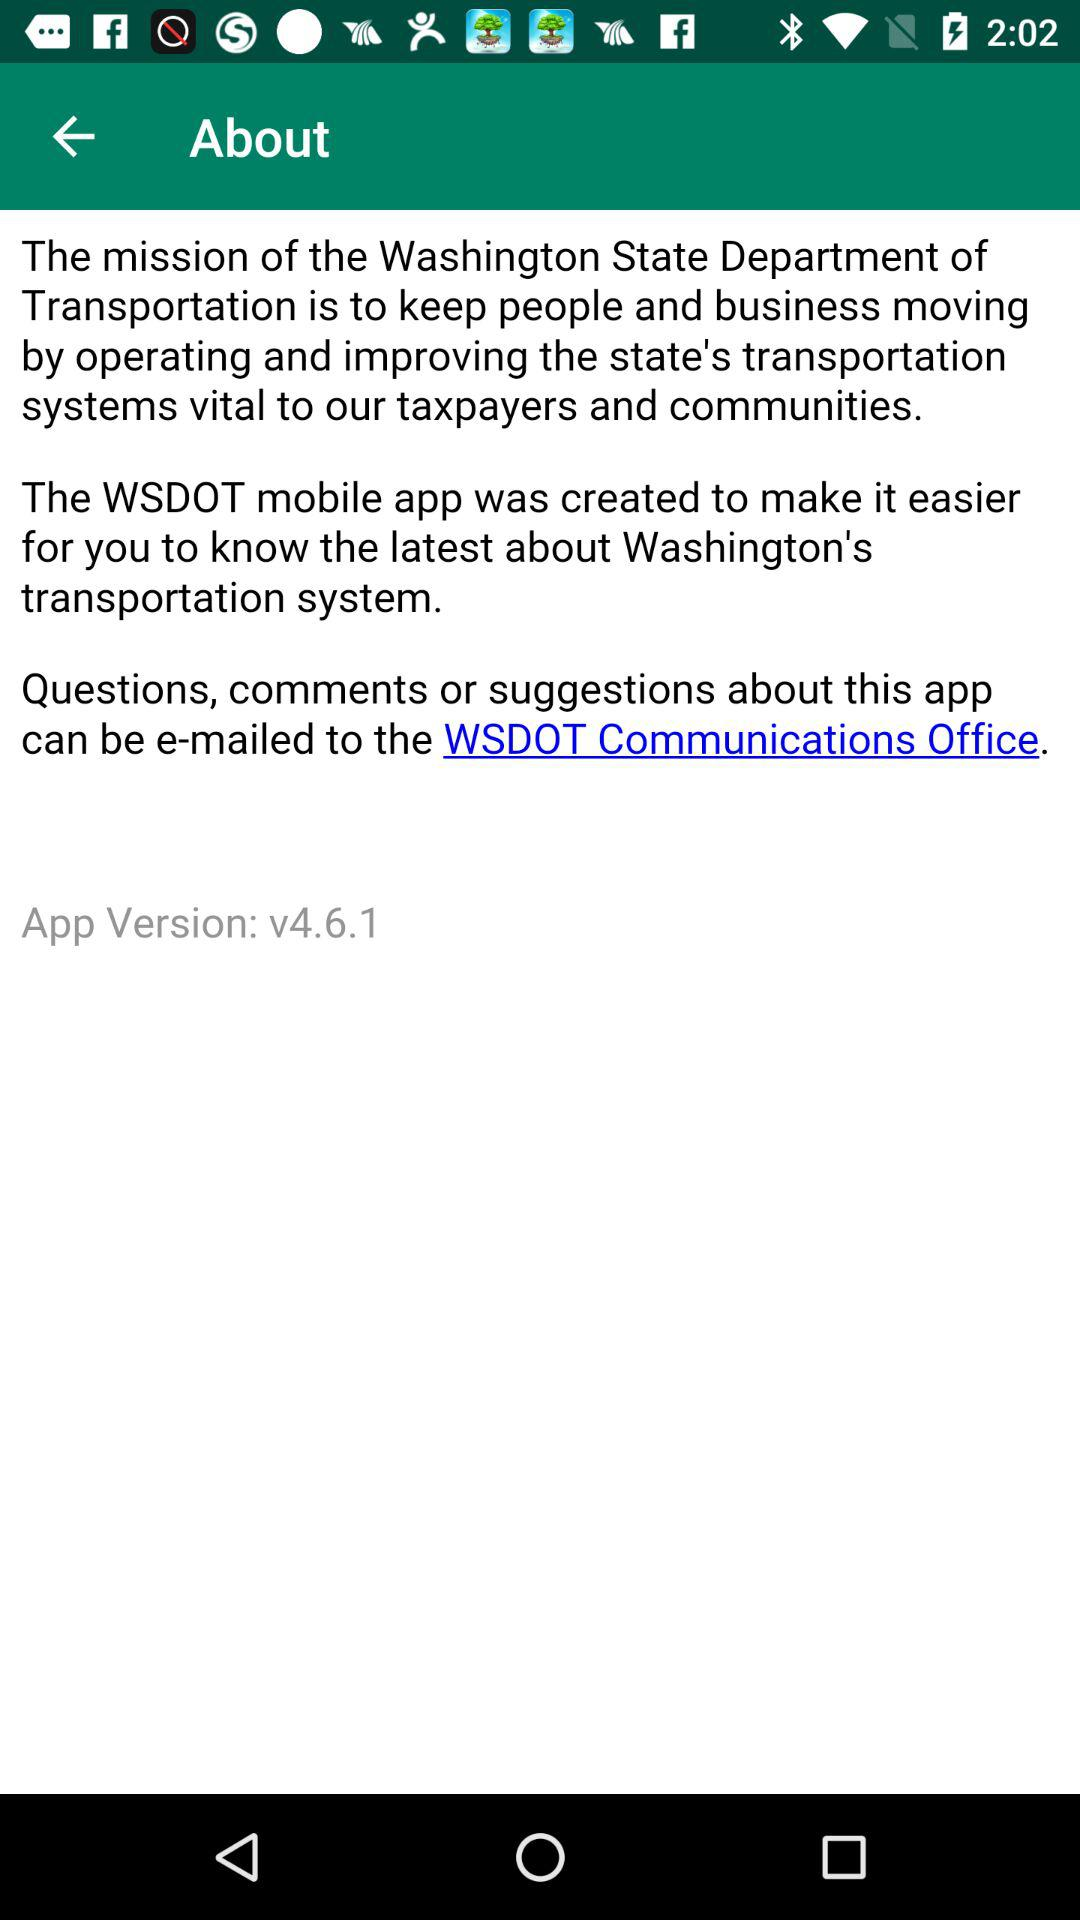What is the app version? The app version is v4.6.1. 